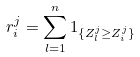Convert formula to latex. <formula><loc_0><loc_0><loc_500><loc_500>r _ { i } ^ { j } = \sum _ { l = 1 } ^ { n } 1 _ { \{ Z _ { l } ^ { j } \geq Z _ { i } ^ { j } \} }</formula> 